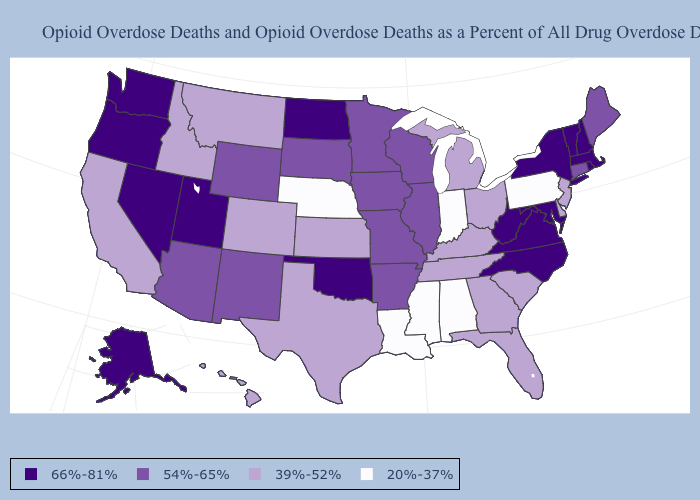Name the states that have a value in the range 39%-52%?
Short answer required. California, Colorado, Delaware, Florida, Georgia, Hawaii, Idaho, Kansas, Kentucky, Michigan, Montana, New Jersey, Ohio, South Carolina, Tennessee, Texas. Which states hav the highest value in the West?
Write a very short answer. Alaska, Nevada, Oregon, Utah, Washington. Name the states that have a value in the range 39%-52%?
Keep it brief. California, Colorado, Delaware, Florida, Georgia, Hawaii, Idaho, Kansas, Kentucky, Michigan, Montana, New Jersey, Ohio, South Carolina, Tennessee, Texas. Name the states that have a value in the range 54%-65%?
Keep it brief. Arizona, Arkansas, Connecticut, Illinois, Iowa, Maine, Minnesota, Missouri, New Mexico, South Dakota, Wisconsin, Wyoming. What is the value of New York?
Answer briefly. 66%-81%. Which states have the lowest value in the USA?
Keep it brief. Alabama, Indiana, Louisiana, Mississippi, Nebraska, Pennsylvania. Among the states that border Massachusetts , which have the lowest value?
Write a very short answer. Connecticut. What is the value of Maryland?
Concise answer only. 66%-81%. What is the highest value in states that border Oregon?
Keep it brief. 66%-81%. Among the states that border Oregon , which have the lowest value?
Concise answer only. California, Idaho. Name the states that have a value in the range 54%-65%?
Write a very short answer. Arizona, Arkansas, Connecticut, Illinois, Iowa, Maine, Minnesota, Missouri, New Mexico, South Dakota, Wisconsin, Wyoming. What is the highest value in the Northeast ?
Concise answer only. 66%-81%. Which states hav the highest value in the Northeast?
Give a very brief answer. Massachusetts, New Hampshire, New York, Rhode Island, Vermont. Name the states that have a value in the range 54%-65%?
Keep it brief. Arizona, Arkansas, Connecticut, Illinois, Iowa, Maine, Minnesota, Missouri, New Mexico, South Dakota, Wisconsin, Wyoming. Does the map have missing data?
Write a very short answer. No. 